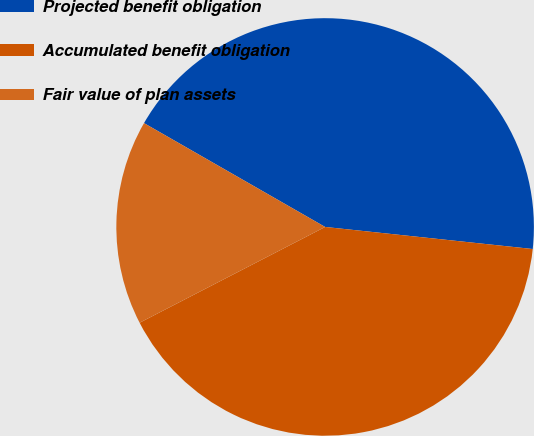Convert chart. <chart><loc_0><loc_0><loc_500><loc_500><pie_chart><fcel>Projected benefit obligation<fcel>Accumulated benefit obligation<fcel>Fair value of plan assets<nl><fcel>43.4%<fcel>40.73%<fcel>15.87%<nl></chart> 